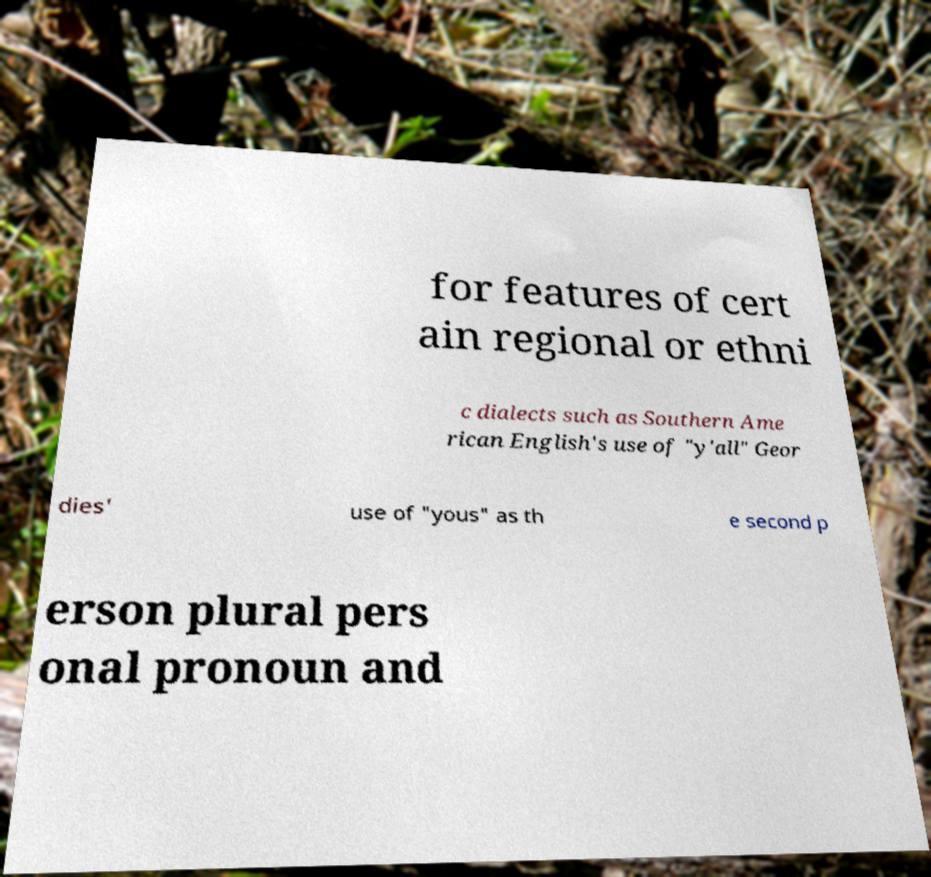There's text embedded in this image that I need extracted. Can you transcribe it verbatim? for features of cert ain regional or ethni c dialects such as Southern Ame rican English's use of "y'all" Geor dies' use of "yous" as th e second p erson plural pers onal pronoun and 